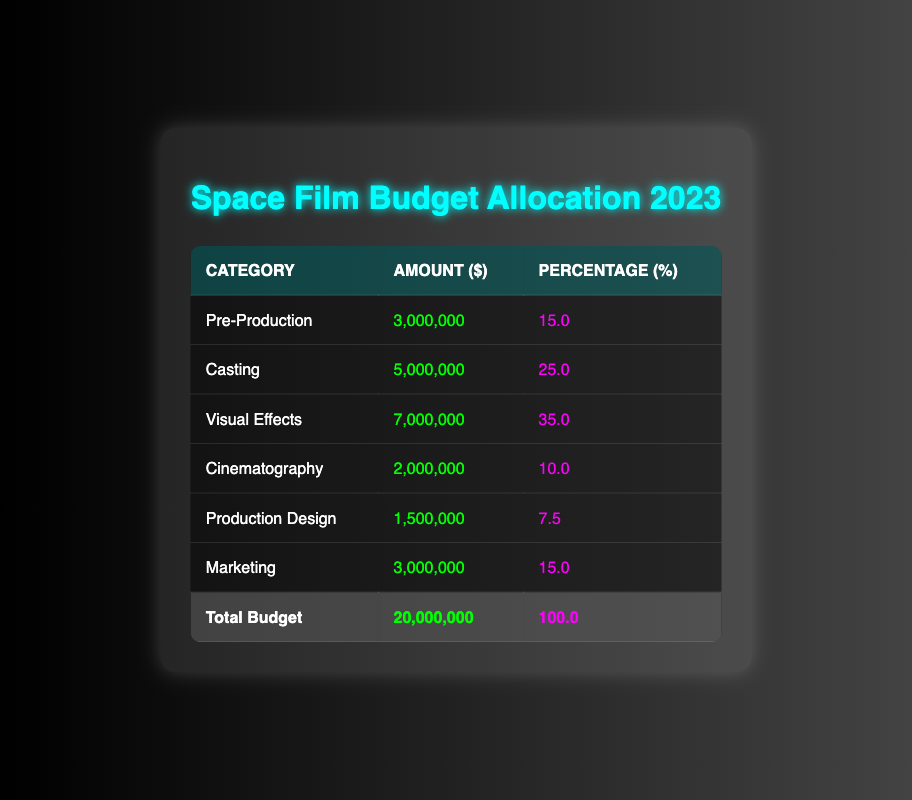What is the total budget allocated for the space-themed film in 2023? The total budget is given in the table under the "Total Budget" row, with the amount listed as 20,000,000.
Answer: 20,000,000 How much is allocated to Visual Effects? The amount allocated to Visual Effects is specified in the corresponding row of the table, which shows 7,000,000.
Answer: 7,000,000 What percentage of the total budget is allocated for Casting? The table indicates that the percentage for Casting is listed next to the amount in its row, which is 25%.
Answer: 25% Which category has the highest budget allocation? By comparing the amounts listed in each category, Visual Effects has the highest amount with 7,000,000.
Answer: Visual Effects What is the total amount allocated for Cinematography and Production Design combined? Adding the amounts for Cinematography (2,000,000) and Production Design (1,500,000): 2,000,000 + 1,500,000 = 3,500,000 gives the total.
Answer: 3,500,000 Does Marketing receive more funding than Pre-Production? The amount allocated for Marketing is 3,000,000 while Pre-Production receives 3,000,000 as well. Thus, the statement is false as they are equal.
Answer: No What fraction of the total budget does Visual Effects represent? The fraction is calculated by dividing the amount for Visual Effects (7,000,000) by the total budget (20,000,000): 7,000,000 / 20,000,000 = 0.35, which means it represents 35% of the total budget.
Answer: 0.35 If we combine the funding for Pre-Production and Marketing, what percentage of the total budget would that represent? Adding Pre-Production (3,000,000) and Marketing (3,000,000) gives 6,000,000. The percentage is then calculated as (6,000,000 / 20,000,000) * 100 = 30%.
Answer: 30% Is the amount allocated for Production Design less than 10% of the total budget? The amount for Production Design is 1,500,000. To find the percentage, it is calculated as (1,500,000 / 20,000,000) * 100 = 7.5%, which is indeed less than 10%.
Answer: Yes 